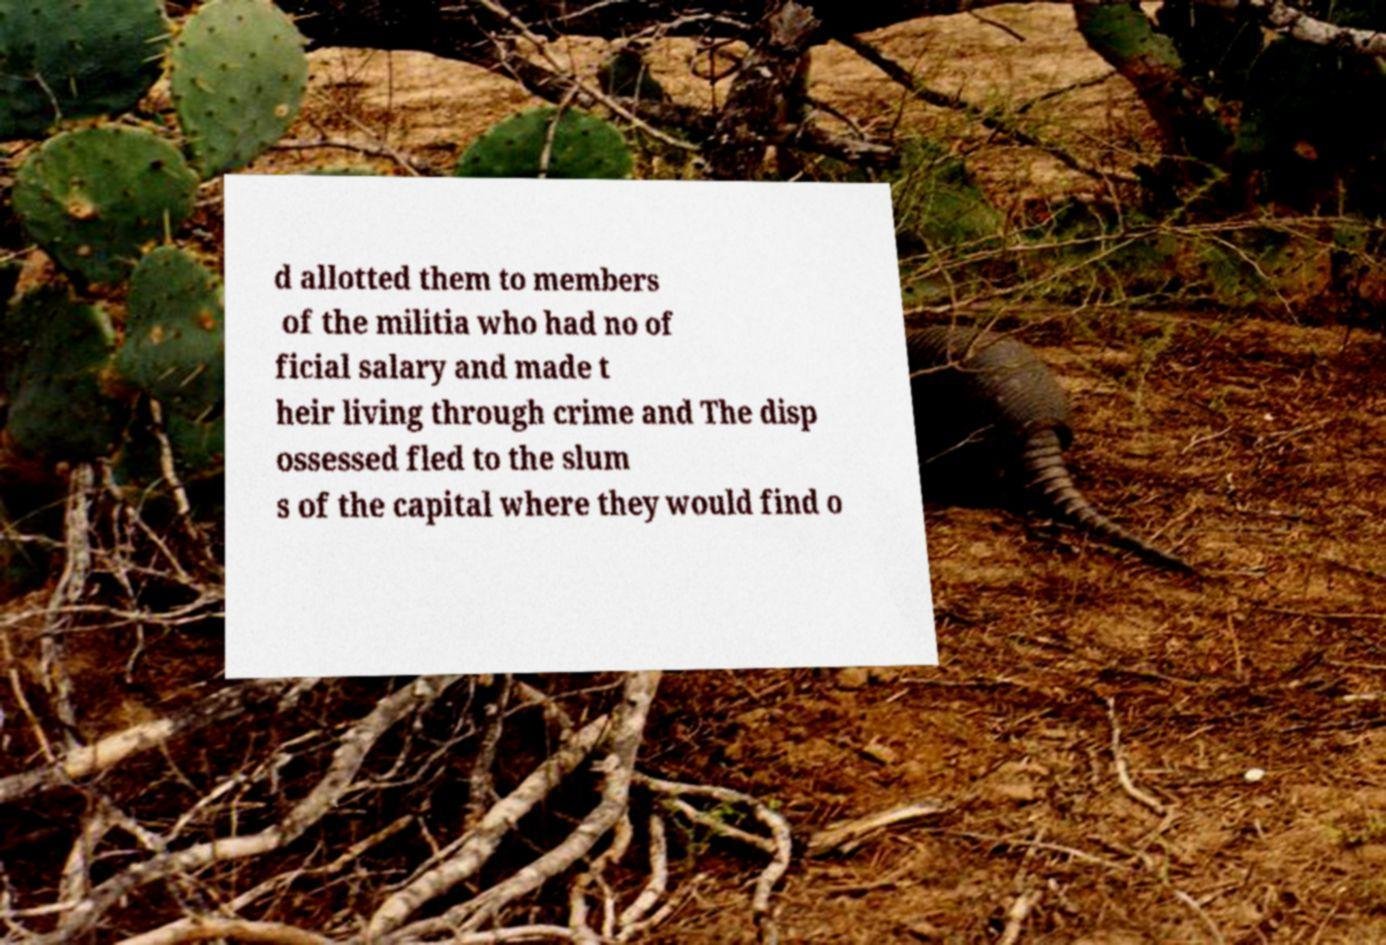Could you assist in decoding the text presented in this image and type it out clearly? d allotted them to members of the militia who had no of ficial salary and made t heir living through crime and The disp ossessed fled to the slum s of the capital where they would find o 